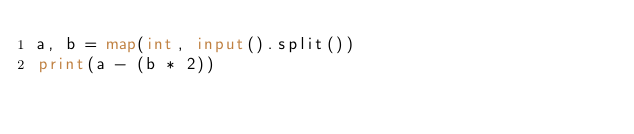<code> <loc_0><loc_0><loc_500><loc_500><_Python_>a, b = map(int, input().split())
print(a - (b * 2))</code> 